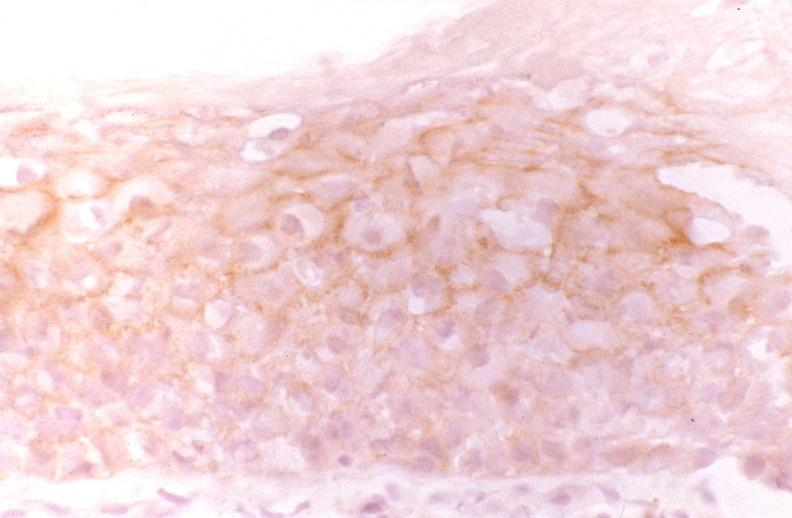s source present?
Answer the question using a single word or phrase. No 